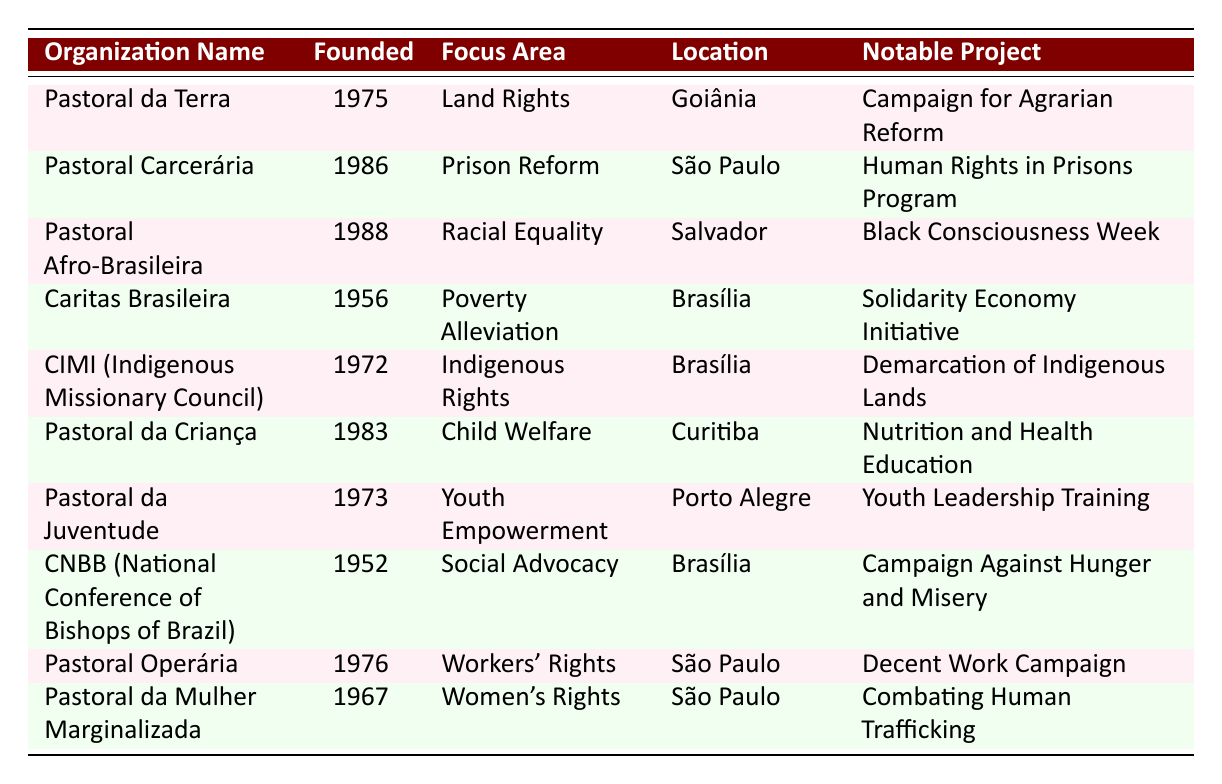What is the focus area of Pastoral Afro-Brasileira? The table states that Pastoral Afro-Brasileira focuses on "Racial Equality."
Answer: Racial Equality Which organization was founded first, CNBB or Caritas Brasileira? By comparing the founding years listed in the table, CNBB was founded in 1952 and Caritas Brasileira was founded in 1956. Since 1952 is earlier than 1956, CNBB was founded first.
Answer: CNBB How many organizations focus on social advocacy or related areas? The table shows that CNBB focuses on "Social Advocacy," and the Pastoral Carcerária focuses on "Prison Reform" which relates to social justice. Therefore, there are two organizations directly related to social advocacy or similar areas.
Answer: Two Is there an organization that focuses on Women's Rights located in São Paulo? Yes, the table lists "Pastoral da Mulher Marginalizada" as focusing on Women's Rights in São Paulo.
Answer: Yes Which notable project is associated with the Pastoral da Juventude? According to the table, the notable project associated with the Pastoral da Juventude is "Youth Leadership Training."
Answer: Youth Leadership Training How many organizations have their headquarters in Brasília? The table shows that Caritas Brasileira, CIMI, and CNBB are located in Brasília. Counting these organizations gives a total of three organizations headquartered there.
Answer: Three What is the difference in founding years between the oldest and the youngest organization listed? The oldest organization is CNBB, founded in 1952, and the youngest is Pastoral Afro-Brasileira, founded in 1988. To find the difference, we subtract 1952 from 1988, which is 36 years.
Answer: 36 Which organization has a notable project related to nutrition? The table indicates that "Pastoral da Criança" has a notable project titled "Nutrition and Health Education."
Answer: Pastoral da Criança 